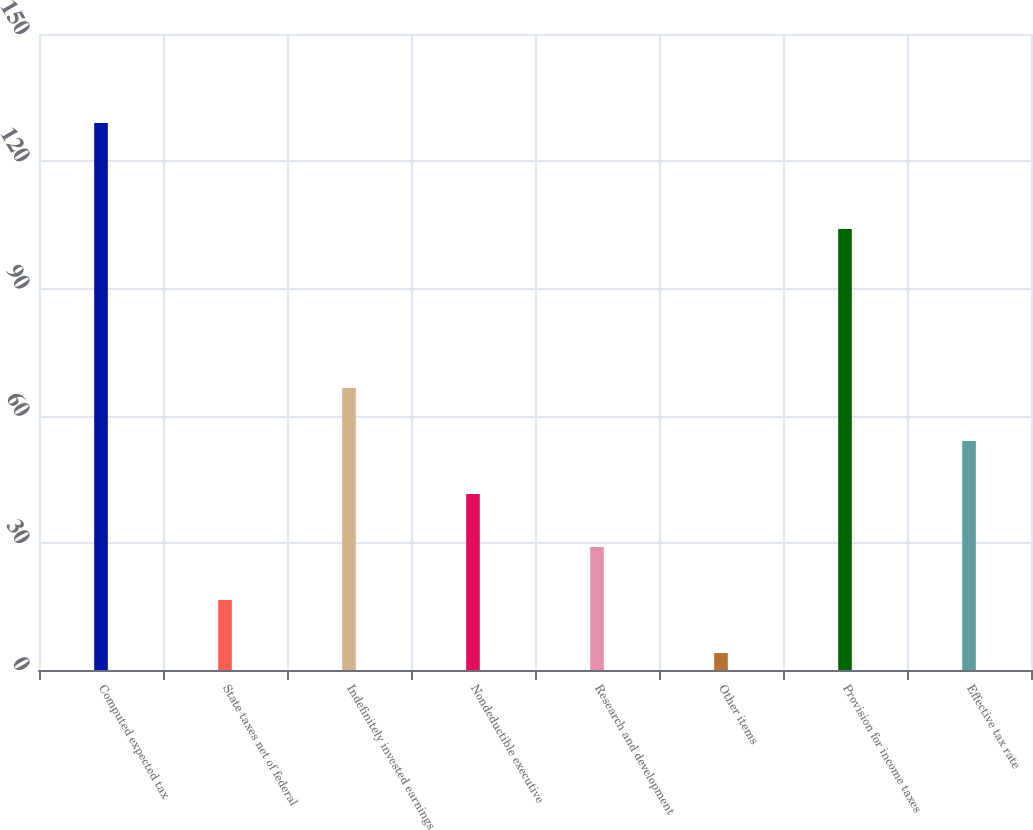Convert chart. <chart><loc_0><loc_0><loc_500><loc_500><bar_chart><fcel>Computed expected tax<fcel>State taxes net of federal<fcel>Indefinitely invested earnings<fcel>Nondeductible executive<fcel>Research and development<fcel>Other items<fcel>Provision for income taxes<fcel>Effective tax rate<nl><fcel>129<fcel>16.5<fcel>66.5<fcel>41.5<fcel>29<fcel>4<fcel>104<fcel>54<nl></chart> 